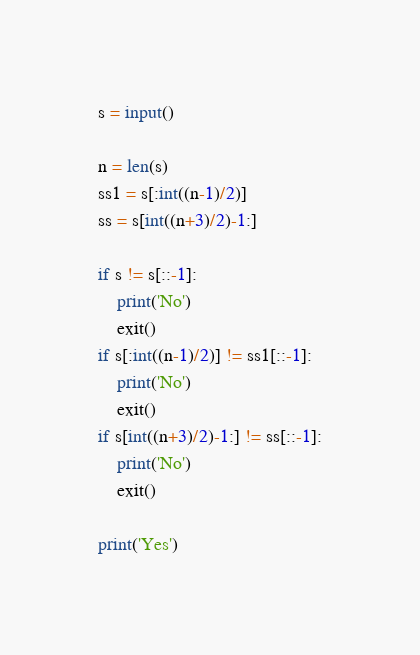<code> <loc_0><loc_0><loc_500><loc_500><_Python_>s = input()

n = len(s)
ss1 = s[:int((n-1)/2)]
ss = s[int((n+3)/2)-1:]

if s != s[::-1]:
    print('No')
    exit()
if s[:int((n-1)/2)] != ss1[::-1]:
    print('No')
    exit()
if s[int((n+3)/2)-1:] != ss[::-1]:
    print('No')
    exit()

print('Yes')
</code> 